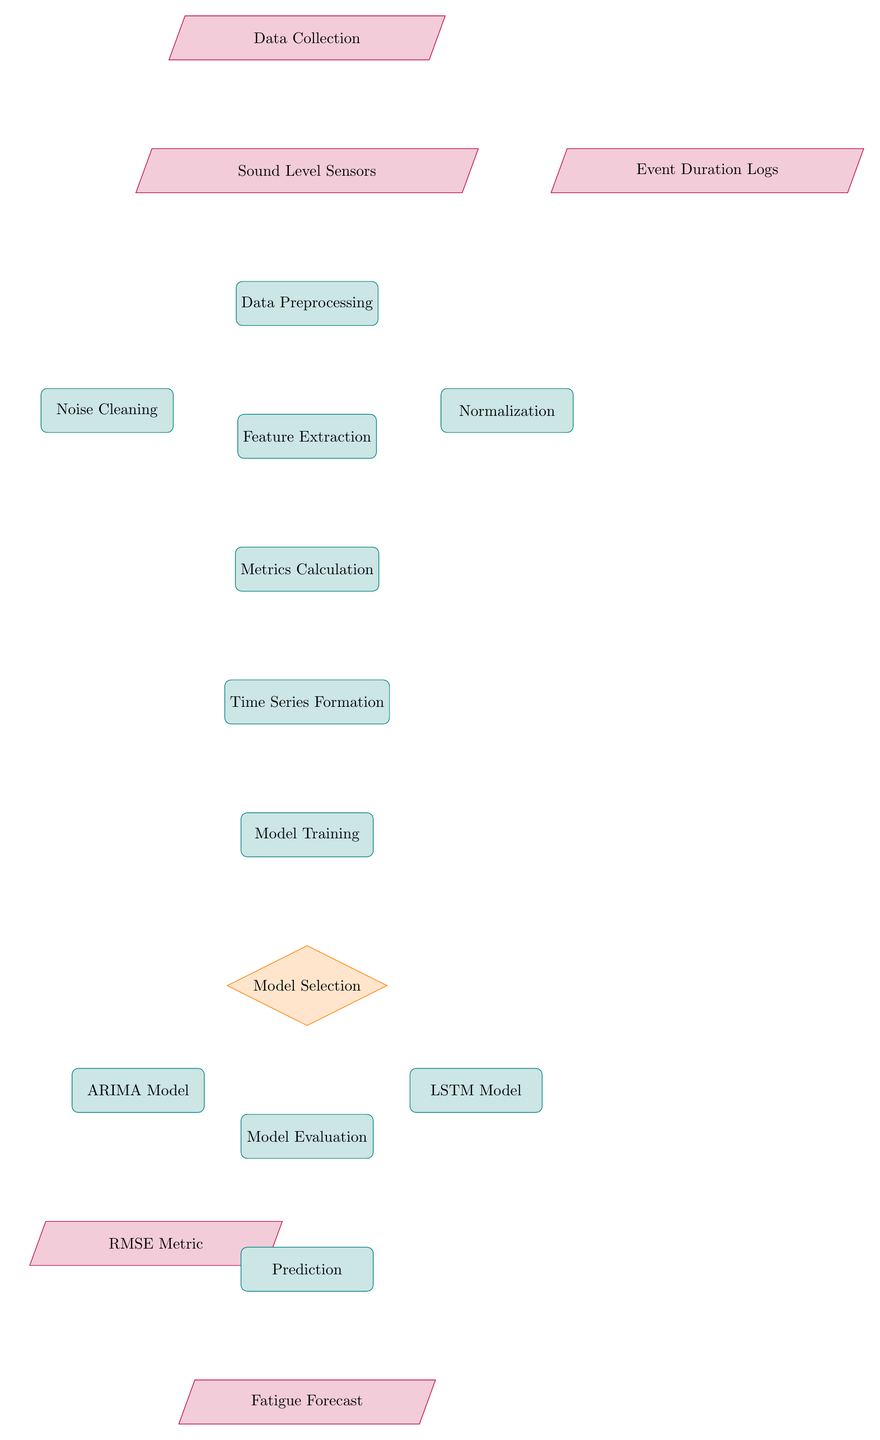What is the first step in the diagram? The first step, labeled "Data Collection," indicates the initiation of the process. It is the starting point from which all other processes flow.
Answer: Data Collection How many models are selected for training in this process? The diagram shows two models under the "Model Selection" node: ARIMA Model and LSTM Model, indicating that two models are selected for training in this process.
Answer: Two Which process follows "Time Series Formation"? The process labeled "Model Training" immediately follows the "Time Series Formation," which shows the sequential flow of operations.
Answer: Model Training What metric is used for evaluation in the diagram? The diagram includes the "RMSE Metric" as one of the output data nodes from the "Model Evaluation" process, indicating that this metric is used for evaluation.
Answer: RMSE Metric What data streams into the "Data Preprocessing" node? The "Data Preprocessing" node receives input from two sources: "Sound Level Sensors" and "Event Duration Logs," indicating these are the data streams that feed into this process.
Answer: Sound Level Sensors, Event Duration Logs What is the output of the "Prediction" process? The output of the "Prediction" process is labeled as "Fatigue Forecast," indicating that the final outcome of this process is the forecast related to fatigue.
Answer: Fatigue Forecast What comes between "Metrics Calculation" and "Model Training"? "Time Series Formation" is the process that comes between "Metrics Calculation" and "Model Training," indicating a step in the workflow before training the models.
Answer: Time Series Formation Which model is one of the options in "Model Selection"? The "ARIMA Model" is one of the options presented under the decision node labeled "Model Selection," indicating it is a candidate for training.
Answer: ARIMA Model What is the relation between "Noise Cleaning" and "Data Preprocessing"? "Noise Cleaning" is a subprocess that stems from the main process "Data Preprocessing," indicating that it is a specific task performed as part of preprocessing the data.
Answer: subprocess 